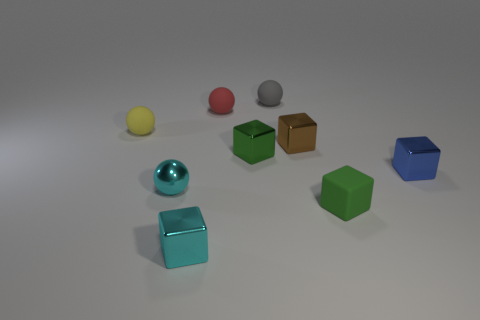Subtract all red spheres. How many green blocks are left? 2 Subtract all tiny cyan spheres. How many spheres are left? 3 Add 1 green blocks. How many objects exist? 10 Subtract 3 blocks. How many blocks are left? 2 Subtract all cyan spheres. How many spheres are left? 3 Subtract all green spheres. Subtract all yellow cubes. How many spheres are left? 4 Subtract all cubes. How many objects are left? 4 Add 7 purple metal cylinders. How many purple metal cylinders exist? 7 Subtract 0 blue cylinders. How many objects are left? 9 Subtract all large cyan matte cubes. Subtract all small red matte objects. How many objects are left? 8 